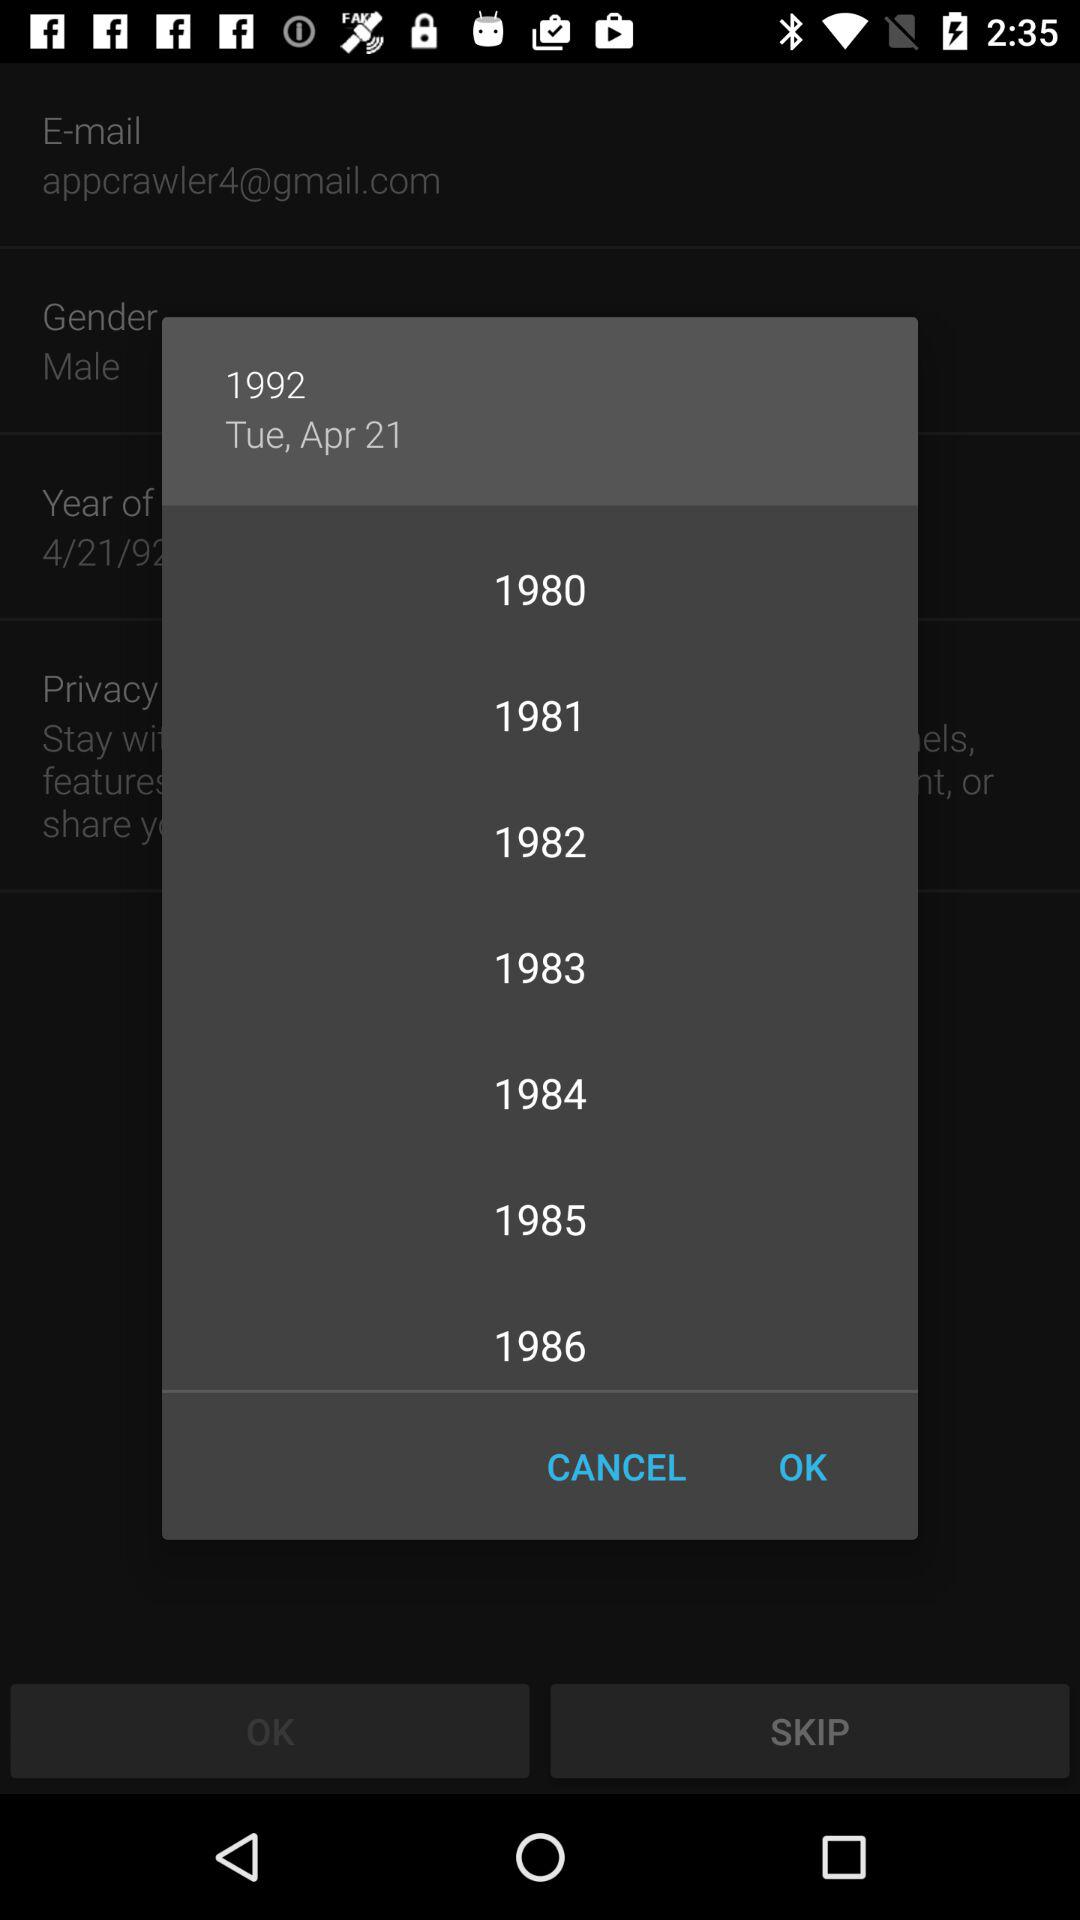What is the date? The date is Tuesday, April 21, 1992. 